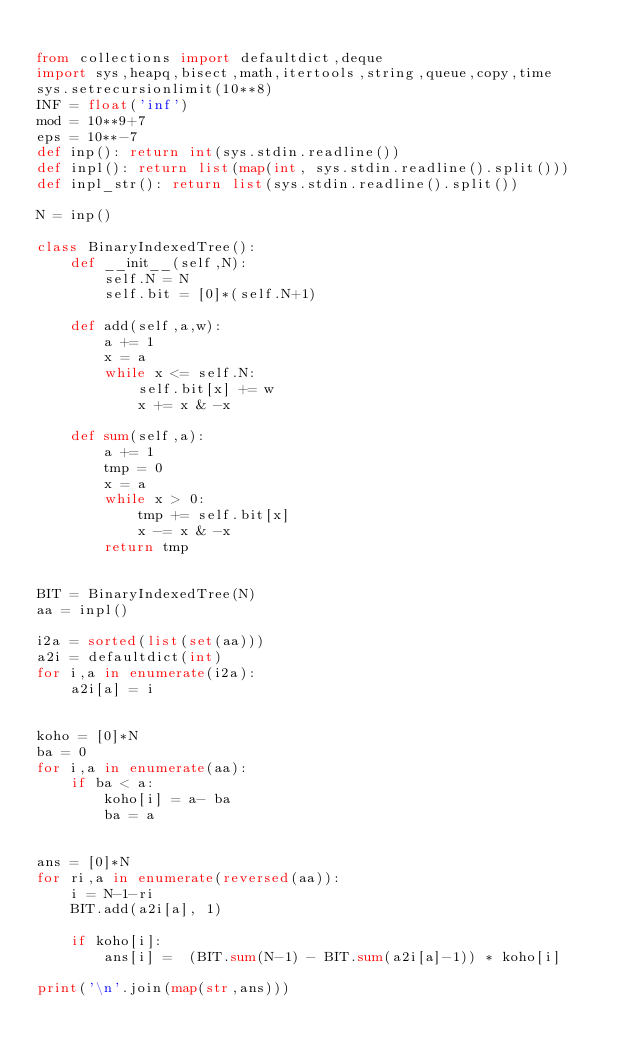Convert code to text. <code><loc_0><loc_0><loc_500><loc_500><_Python_>
from collections import defaultdict,deque
import sys,heapq,bisect,math,itertools,string,queue,copy,time
sys.setrecursionlimit(10**8)
INF = float('inf')
mod = 10**9+7
eps = 10**-7
def inp(): return int(sys.stdin.readline())
def inpl(): return list(map(int, sys.stdin.readline().split()))
def inpl_str(): return list(sys.stdin.readline().split())

N = inp()

class BinaryIndexedTree():
    def __init__(self,N):
        self.N = N
        self.bit = [0]*(self.N+1)

    def add(self,a,w):
        a += 1
        x = a
        while x <= self.N:
            self.bit[x] += w
            x += x & -x

    def sum(self,a):
        a += 1
        tmp = 0
        x = a
        while x > 0:
            tmp += self.bit[x]
            x -= x & -x
        return tmp


BIT = BinaryIndexedTree(N)
aa = inpl()

i2a = sorted(list(set(aa)))
a2i = defaultdict(int)
for i,a in enumerate(i2a):
    a2i[a] = i


koho = [0]*N
ba = 0
for i,a in enumerate(aa):
    if ba < a:
        koho[i] = a- ba
        ba = a


ans = [0]*N
for ri,a in enumerate(reversed(aa)):
    i = N-1-ri
    BIT.add(a2i[a], 1)

    if koho[i]:
        ans[i] =  (BIT.sum(N-1) - BIT.sum(a2i[a]-1)) * koho[i]

print('\n'.join(map(str,ans)))
</code> 